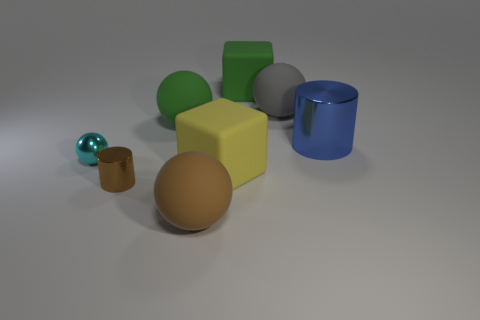Subtract all tiny metal balls. How many balls are left? 3 Add 1 blue things. How many objects exist? 9 Subtract all brown cylinders. How many cylinders are left? 1 Subtract all cylinders. How many objects are left? 6 Subtract 3 spheres. How many spheres are left? 1 Subtract all brown spheres. Subtract all green objects. How many objects are left? 5 Add 6 tiny objects. How many tiny objects are left? 8 Add 1 blue shiny cylinders. How many blue shiny cylinders exist? 2 Subtract 1 brown spheres. How many objects are left? 7 Subtract all cyan cubes. Subtract all cyan balls. How many cubes are left? 2 